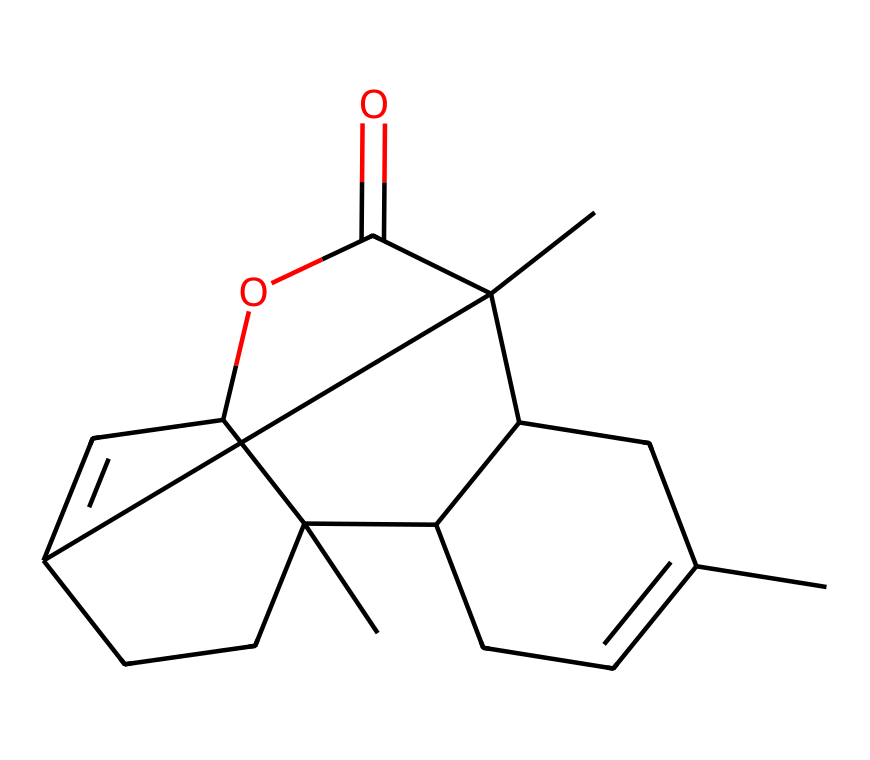What is the molecular formula of myrrh in the given structure? To derive the molecular formula from the SMILES representation, identify the types of atoms indicated. In the structure, count the carbon (C), hydrogen (H), and oxygen (O) atoms. The chemical represents 15 carbon atoms, 24 hydrogen atoms, and 3 oxygen atoms. Thus, the formula is C15H24O3.
Answer: C15H24O3 How many chiral centers are present in myrrh? Analyze the chemical structure to find any chiral centers, which are typically carbons attached to four different substituents. By inspecting the structure, there are four carbon atoms that fit this criterion, indicating that there are four chiral centers.
Answer: 4 What is the significance of myrrh in traditional medicine? Myrrh has been historically used for its anti-inflammatory, antiseptic, and antimicrobial properties, making it significant in various traditional medicinal practices.
Answer: medicinal properties Which part of the myrrh structure contributes to its chirality? Chirality in myrrh arises from the four carbon atoms where each is bonded to four different groups or atoms. These chiral centers create non-superimposable mirror images, contributing to the overall chiral nature of the compound.
Answer: chiral centers How many rings are present in the chemical structure of myrrh? By examining the structure, identify any cyclic components. There are three fused rings in the chemical structure of myrrh, as observed by the interconnected carbon cycles.
Answer: 3 Is myrrh classified as a terpene compound? Myrrh’s structure reveals it features a complex cyclic structure typical of terpenes, which are compounds derived from isoprene units. Thus, it confirms that myrrh is indeed classified as a terpene.
Answer: yes 